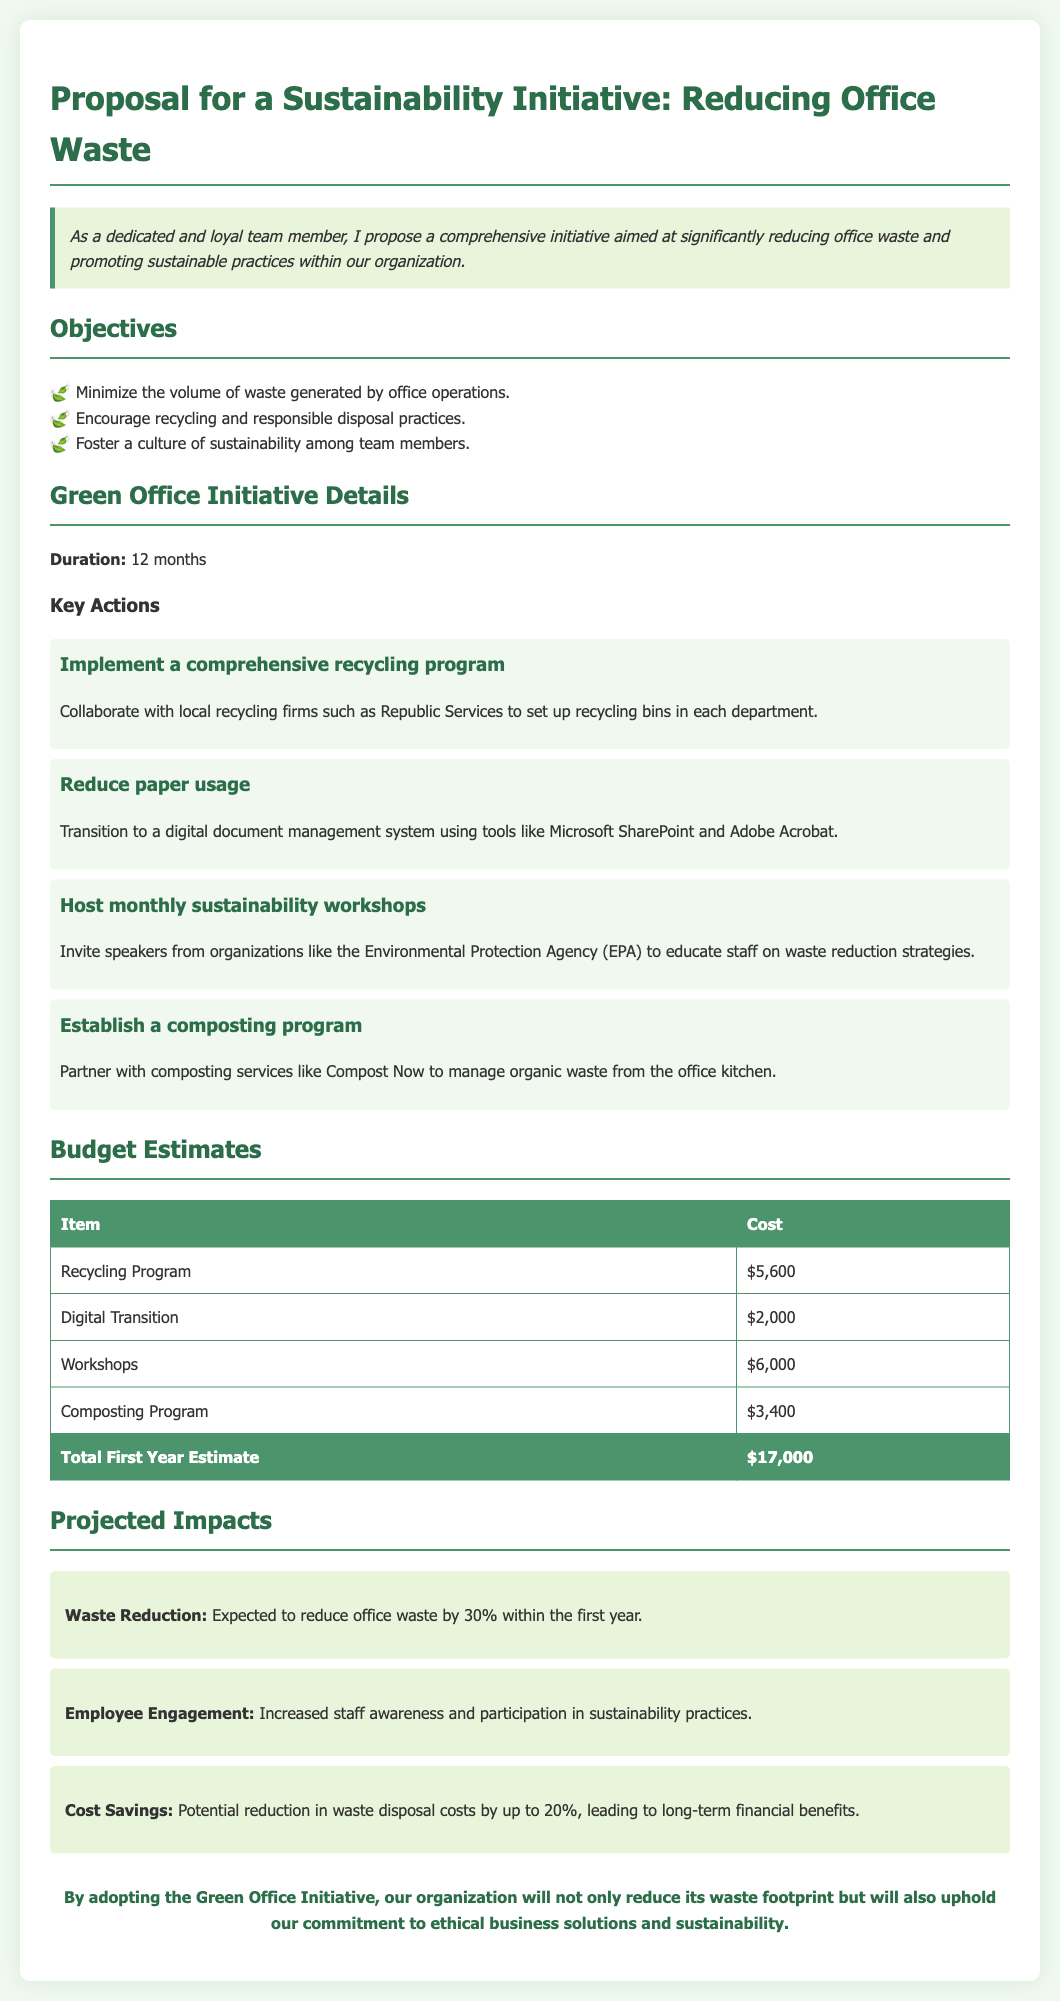what is the total first year estimate? The total first year estimate is presented in the budget estimates section as the sum of all listed costs, which is $17,000.
Answer: $17,000 how much is allocated for the recycling program? The budget estimates outline the cost for the recycling program, which is $5,600.
Answer: $5,600 what is one of the key actions mentioned in the proposal? The proposal lists various key actions to take, one of which is to implement a comprehensive recycling program.
Answer: implement a comprehensive recycling program which organization will be invited to educate staff on sustainability? The document mentions inviting speakers from the Environmental Protection Agency (EPA) for workshops.
Answer: Environmental Protection Agency (EPA) what is the expected percentage reduction in office waste? The projected impacts state the expected reduction in office waste by 30% within the first year.
Answer: 30% how long is the duration of the initiative? The duration of the initiative is specified as 12 months.
Answer: 12 months what is one projected impact related to cost savings? The proposal mentions a potential reduction in waste disposal costs by up to 20%, indicating financial benefits.
Answer: 20% who is responsible for managing organic waste according to the proposal? The document states that a partner like Compost Now will manage organic waste from the office kitchen.
Answer: Compost Now what is the main objective of the initiative? One of the primary objectives is to minimize the volume of waste generated by office operations.
Answer: minimize the volume of waste generated by office operations 